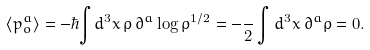Convert formula to latex. <formula><loc_0><loc_0><loc_500><loc_500>\langle p _ { o } ^ { a } \rangle = - \hbar { \int } d ^ { 3 } x \, \rho \, \partial ^ { a } \log \rho ^ { 1 / 2 } = - \frac { } { 2 } \int d ^ { 3 } x \, \partial ^ { a } \rho = 0 .</formula> 